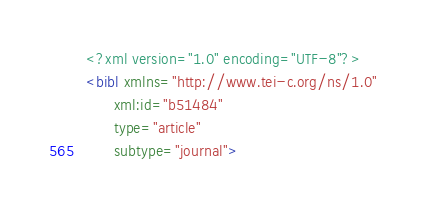Convert code to text. <code><loc_0><loc_0><loc_500><loc_500><_XML_><?xml version="1.0" encoding="UTF-8"?>
<bibl xmlns="http://www.tei-c.org/ns/1.0"
      xml:id="b51484"
      type="article"
      subtype="journal"></code> 